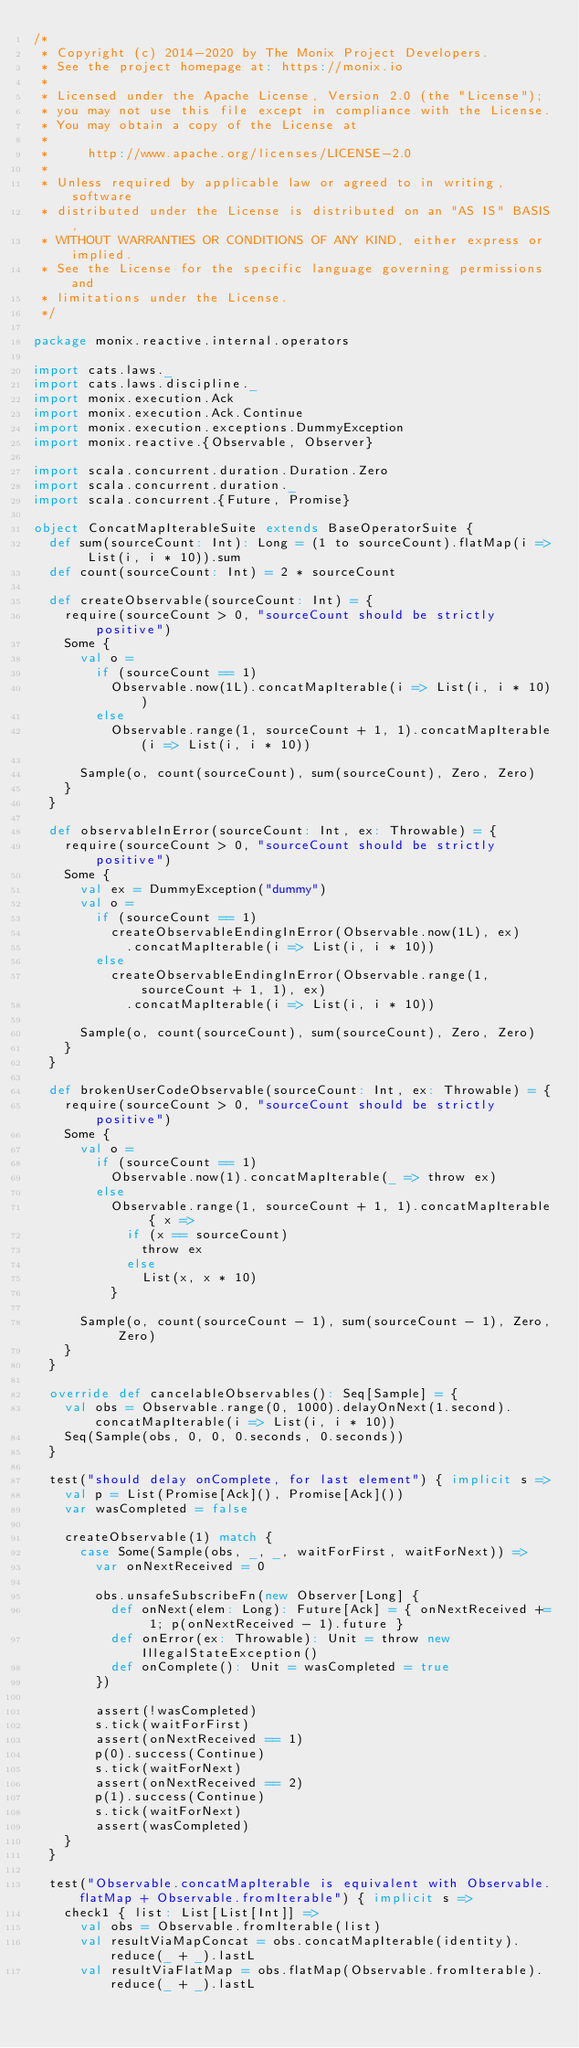Convert code to text. <code><loc_0><loc_0><loc_500><loc_500><_Scala_>/*
 * Copyright (c) 2014-2020 by The Monix Project Developers.
 * See the project homepage at: https://monix.io
 *
 * Licensed under the Apache License, Version 2.0 (the "License");
 * you may not use this file except in compliance with the License.
 * You may obtain a copy of the License at
 *
 *     http://www.apache.org/licenses/LICENSE-2.0
 *
 * Unless required by applicable law or agreed to in writing, software
 * distributed under the License is distributed on an "AS IS" BASIS,
 * WITHOUT WARRANTIES OR CONDITIONS OF ANY KIND, either express or implied.
 * See the License for the specific language governing permissions and
 * limitations under the License.
 */

package monix.reactive.internal.operators

import cats.laws._
import cats.laws.discipline._
import monix.execution.Ack
import monix.execution.Ack.Continue
import monix.execution.exceptions.DummyException
import monix.reactive.{Observable, Observer}

import scala.concurrent.duration.Duration.Zero
import scala.concurrent.duration._
import scala.concurrent.{Future, Promise}

object ConcatMapIterableSuite extends BaseOperatorSuite {
  def sum(sourceCount: Int): Long = (1 to sourceCount).flatMap(i => List(i, i * 10)).sum
  def count(sourceCount: Int) = 2 * sourceCount

  def createObservable(sourceCount: Int) = {
    require(sourceCount > 0, "sourceCount should be strictly positive")
    Some {
      val o =
        if (sourceCount == 1)
          Observable.now(1L).concatMapIterable(i => List(i, i * 10))
        else
          Observable.range(1, sourceCount + 1, 1).concatMapIterable(i => List(i, i * 10))

      Sample(o, count(sourceCount), sum(sourceCount), Zero, Zero)
    }
  }

  def observableInError(sourceCount: Int, ex: Throwable) = {
    require(sourceCount > 0, "sourceCount should be strictly positive")
    Some {
      val ex = DummyException("dummy")
      val o =
        if (sourceCount == 1)
          createObservableEndingInError(Observable.now(1L), ex)
            .concatMapIterable(i => List(i, i * 10))
        else
          createObservableEndingInError(Observable.range(1, sourceCount + 1, 1), ex)
            .concatMapIterable(i => List(i, i * 10))

      Sample(o, count(sourceCount), sum(sourceCount), Zero, Zero)
    }
  }

  def brokenUserCodeObservable(sourceCount: Int, ex: Throwable) = {
    require(sourceCount > 0, "sourceCount should be strictly positive")
    Some {
      val o =
        if (sourceCount == 1)
          Observable.now(1).concatMapIterable(_ => throw ex)
        else
          Observable.range(1, sourceCount + 1, 1).concatMapIterable { x =>
            if (x == sourceCount)
              throw ex
            else
              List(x, x * 10)
          }

      Sample(o, count(sourceCount - 1), sum(sourceCount - 1), Zero, Zero)
    }
  }

  override def cancelableObservables(): Seq[Sample] = {
    val obs = Observable.range(0, 1000).delayOnNext(1.second).concatMapIterable(i => List(i, i * 10))
    Seq(Sample(obs, 0, 0, 0.seconds, 0.seconds))
  }

  test("should delay onComplete, for last element") { implicit s =>
    val p = List(Promise[Ack](), Promise[Ack]())
    var wasCompleted = false

    createObservable(1) match {
      case Some(Sample(obs, _, _, waitForFirst, waitForNext)) =>
        var onNextReceived = 0

        obs.unsafeSubscribeFn(new Observer[Long] {
          def onNext(elem: Long): Future[Ack] = { onNextReceived += 1; p(onNextReceived - 1).future }
          def onError(ex: Throwable): Unit = throw new IllegalStateException()
          def onComplete(): Unit = wasCompleted = true
        })

        assert(!wasCompleted)
        s.tick(waitForFirst)
        assert(onNextReceived == 1)
        p(0).success(Continue)
        s.tick(waitForNext)
        assert(onNextReceived == 2)
        p(1).success(Continue)
        s.tick(waitForNext)
        assert(wasCompleted)
    }
  }

  test("Observable.concatMapIterable is equivalent with Observable.flatMap + Observable.fromIterable") { implicit s =>
    check1 { list: List[List[Int]] =>
      val obs = Observable.fromIterable(list)
      val resultViaMapConcat = obs.concatMapIterable(identity).reduce(_ + _).lastL
      val resultViaFlatMap = obs.flatMap(Observable.fromIterable).reduce(_ + _).lastL
</code> 